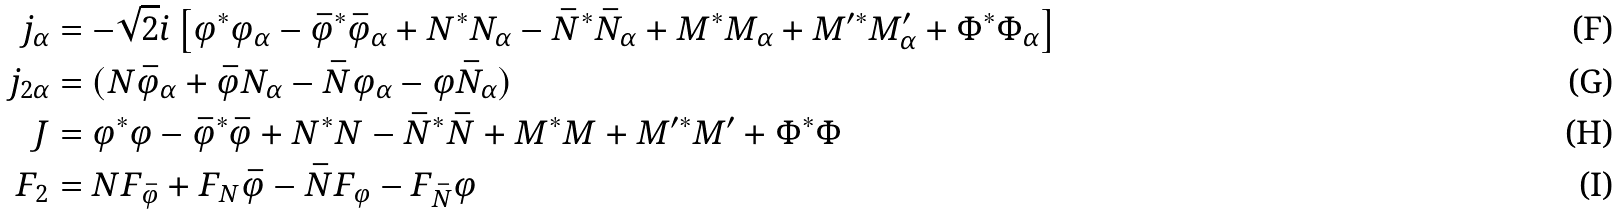<formula> <loc_0><loc_0><loc_500><loc_500>j _ { \alpha } & = - \sqrt { 2 } i \left [ \varphi ^ { * } \varphi _ { \alpha } - \bar { \varphi } ^ { * } \bar { \varphi } _ { \alpha } + N ^ { * } N _ { \alpha } - \bar { N } ^ { * } \bar { N } _ { \alpha } + M ^ { * } M _ { \alpha } + M ^ { \prime * } M ^ { \prime } _ { \alpha } + \Phi ^ { * } \Phi _ { \alpha } \right ] \\ j _ { 2 \alpha } & = ( N \bar { \varphi } _ { \alpha } + \bar { \varphi } N _ { \alpha } - \bar { N } \varphi _ { \alpha } - \varphi \bar { N } _ { \alpha } ) \\ J & = \varphi ^ { * } \varphi - \bar { \varphi } ^ { * } \bar { \varphi } + N ^ { * } N - \bar { N } ^ { * } \bar { N } + M ^ { * } M + M ^ { \prime * } M ^ { \prime } + \Phi ^ { * } \Phi \\ F _ { 2 } & = N F _ { \bar { \varphi } } + F _ { N } \bar { \varphi } - \bar { N } F _ { \varphi } - F _ { \bar { N } } \varphi</formula> 